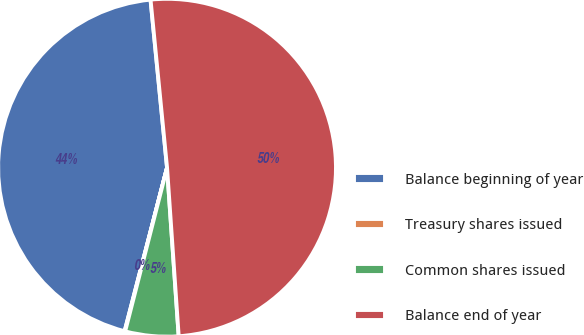Convert chart to OTSL. <chart><loc_0><loc_0><loc_500><loc_500><pie_chart><fcel>Balance beginning of year<fcel>Treasury shares issued<fcel>Common shares issued<fcel>Balance end of year<nl><fcel>44.4%<fcel>0.05%<fcel>5.09%<fcel>50.46%<nl></chart> 